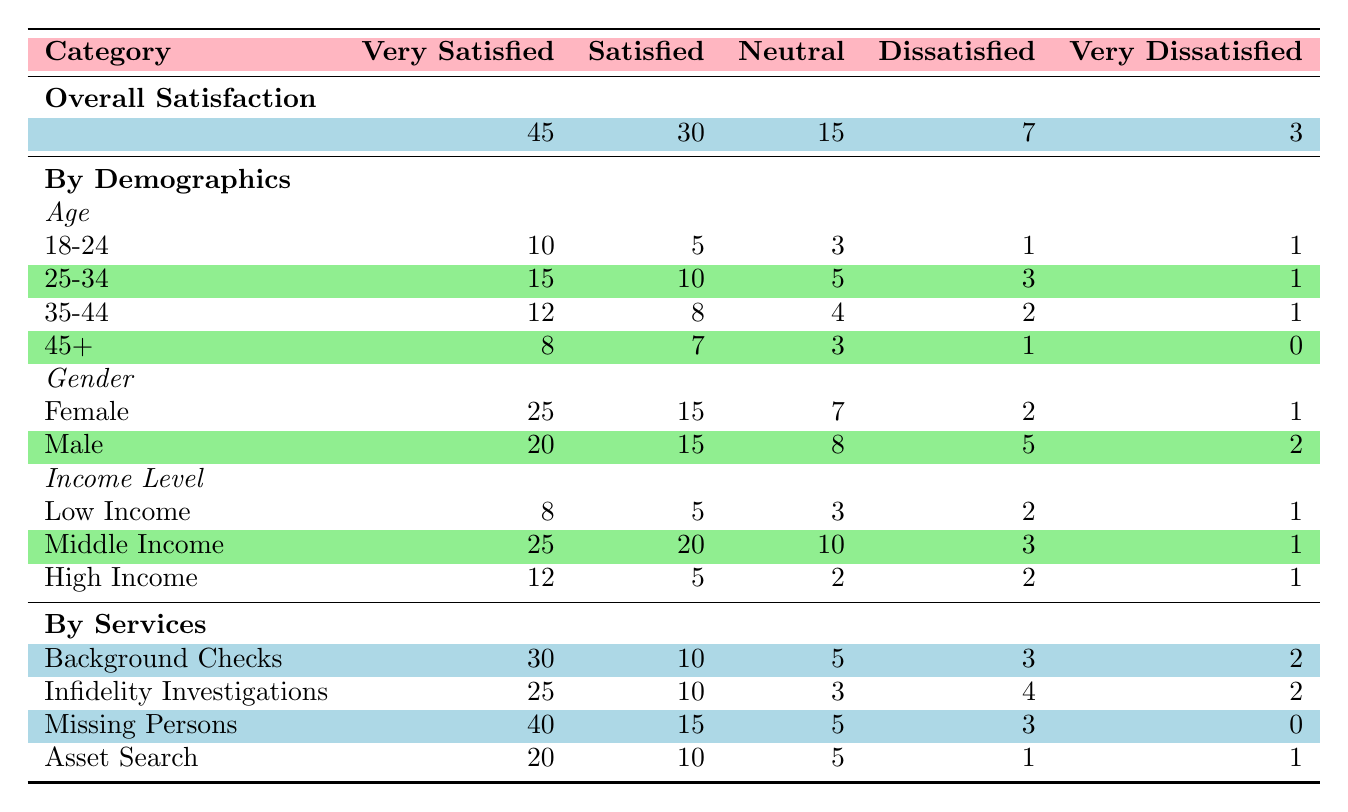What is the total number of clients who are satisfied or very satisfied? To find the total number of clients who are satisfied or very satisfied, we add the values for "satisfied" and "very satisfied." Total = 45 (very satisfied) + 30 (satisfied) = 75.
Answer: 75 How many male clients are very dissatisfied? From the table under the gender section, it shows that there are 2 male clients who are very dissatisfied.
Answer: 2 Which age group has the highest number of clients who are neutral? Reviewing the age groups, the "25-34" age group has the highest number of clients who are neutral—5 clients.
Answer: 25-34 Which service received the least satisfaction? Comparing the number of satisfied and very satisfied clients across the services, "Asset Search" has the fewest satisfied clients with 30 (very satisfied + satisfied).
Answer: Asset Search What percentage of clients reported being very satisfied in the background checks service? For background checks, there are 30 very satisfied clients out of a total of (30 + 10 + 5 + 3 + 2) = 50 clients. The percentage is (30/50) * 100 = 60%.
Answer: 60% Is it true that the middle-income group has more very satisfied clients than the high-income group? Comparing the very satisfied clients, the middle-income group has 25 while the high-income group has 12, confirming that middle-income clients are more very satisfied.
Answer: Yes What is the difference in the number of adults aged 18-24 who are very satisfied versus those aged 45 and older? For 18-24, there are 10 very satisfied clients, and for 45+, there are 8 very satisfied clients. The difference is 10 - 8 = 2.
Answer: 2 Which demographic has the highest percentage of satisfied clients overall? The total number of clients for the female demographic is 25 (very satisfied) + 15 (satisfied) + 7 (neutral) + 2 (dissatisfied) + 1 (very dissatisfied) = 50. The satisfied percentage is (15/50) * 100 = 30%. For males, it is (15/50) * 100 = 30% as well, but females have the same percentage.
Answer: Female and Male What is the average satisfaction level across all clients who participated in missing persons investigations? For missing persons, there are 40 very satisfied, 15 satisfied, 5 neutral, 3 dissatisfied, and 0 very dissatisfied, totaling to 63 clients. Average satisfaction is (40*5 + 15*4 + 5*3 + 3*2 + 0*1)/63 = approximately 3.59.
Answer: Approximately 3.59 